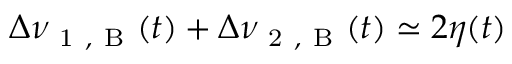Convert formula to latex. <formula><loc_0><loc_0><loc_500><loc_500>\Delta \nu _ { 1 , B } ( t ) + \Delta \nu _ { 2 , B } ( t ) \simeq 2 \eta ( t )</formula> 